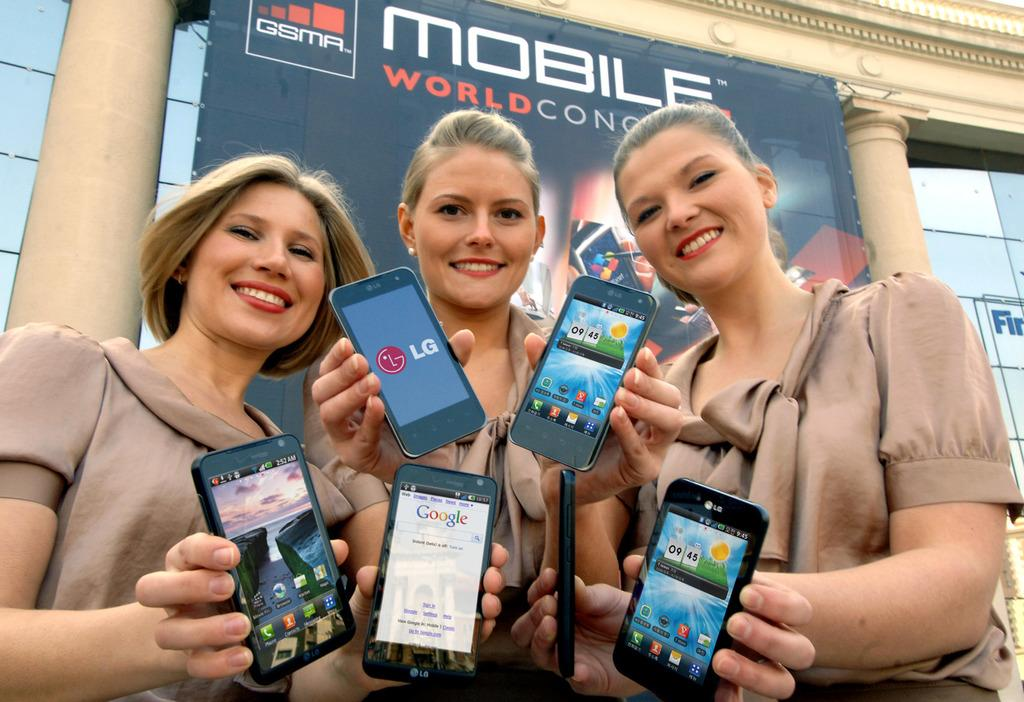<image>
Render a clear and concise summary of the photo. Three women hold up cell phones, one of which is showing the Google search page. 